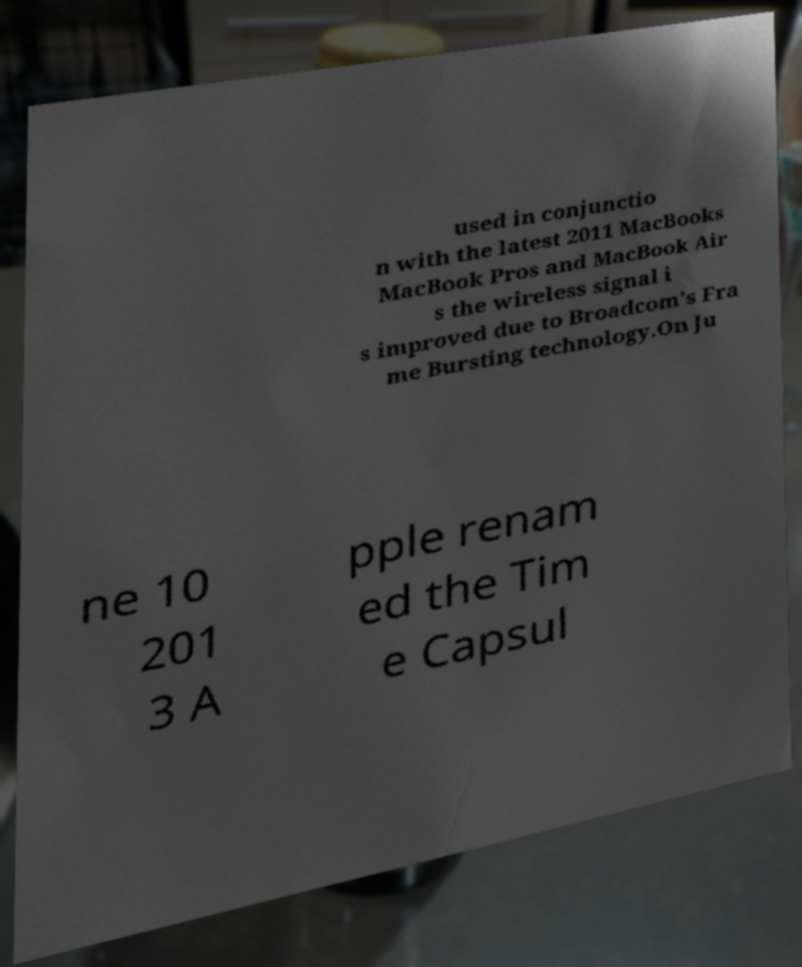Can you accurately transcribe the text from the provided image for me? used in conjunctio n with the latest 2011 MacBooks MacBook Pros and MacBook Air s the wireless signal i s improved due to Broadcom's Fra me Bursting technology.On Ju ne 10 201 3 A pple renam ed the Tim e Capsul 